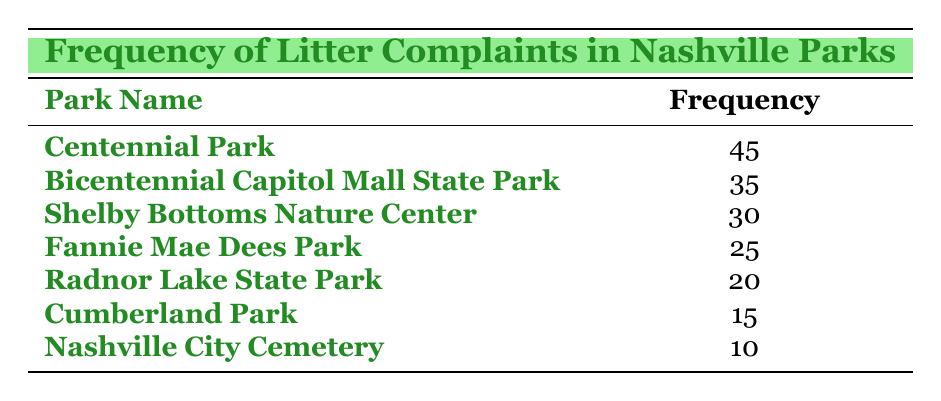What is the park with the highest frequency of litter complaints? From the table, Centennial Park has the highest frequency with a value of 45.
Answer: Centennial Park How many complaints were reported for Bicentennial Capitol Mall State Park? The table indicates Bicentennial Capitol Mall State Park received 35 complaints.
Answer: 35 What is the total number of litter complaints across all parks listed? We sum the frequency values: 45 + 35 + 30 + 25 + 20 + 15 + 10 = 210.
Answer: 210 Is there a park with fewer than 20 complaints? Yes, Cumberland Park and Nashville City Cemetery both have fewer than 20 complaints (15 and 10, respectively).
Answer: Yes Which park had the second lowest number of complaints? By inspecting the frequencies, Cumberland Park has 15 complaints and Nashville City Cemetery has 10, so Cumberland Park is the second lowest.
Answer: Cumberland Park What is the average number of complaints per park? There are 7 parks in total. We previously calculated the total complaints (210), so the average is 210/7 = 30.
Answer: 30 Is the frequency of complaints for Fannie Mae Dees Park greater than that for Radnor Lake State Park? Yes, Fannie Mae Dees Park has 25 complaints, while Radnor Lake State Park has only 20.
Answer: Yes What is the difference in complaint frequencies between Centennial Park and Cumberland Park? The frequency for Centennial Park is 45, and for Cumberland Park, it's 15. The difference is 45 - 15 = 30.
Answer: 30 How many parks received more than 20 complaints? The parks with more than 20 complaints are Centennial Park, Bicentennial Capitol Mall State Park, Shelby Bottoms Nature Center, and Fannie Mae Dees Park, totaling 4 parks.
Answer: 4 